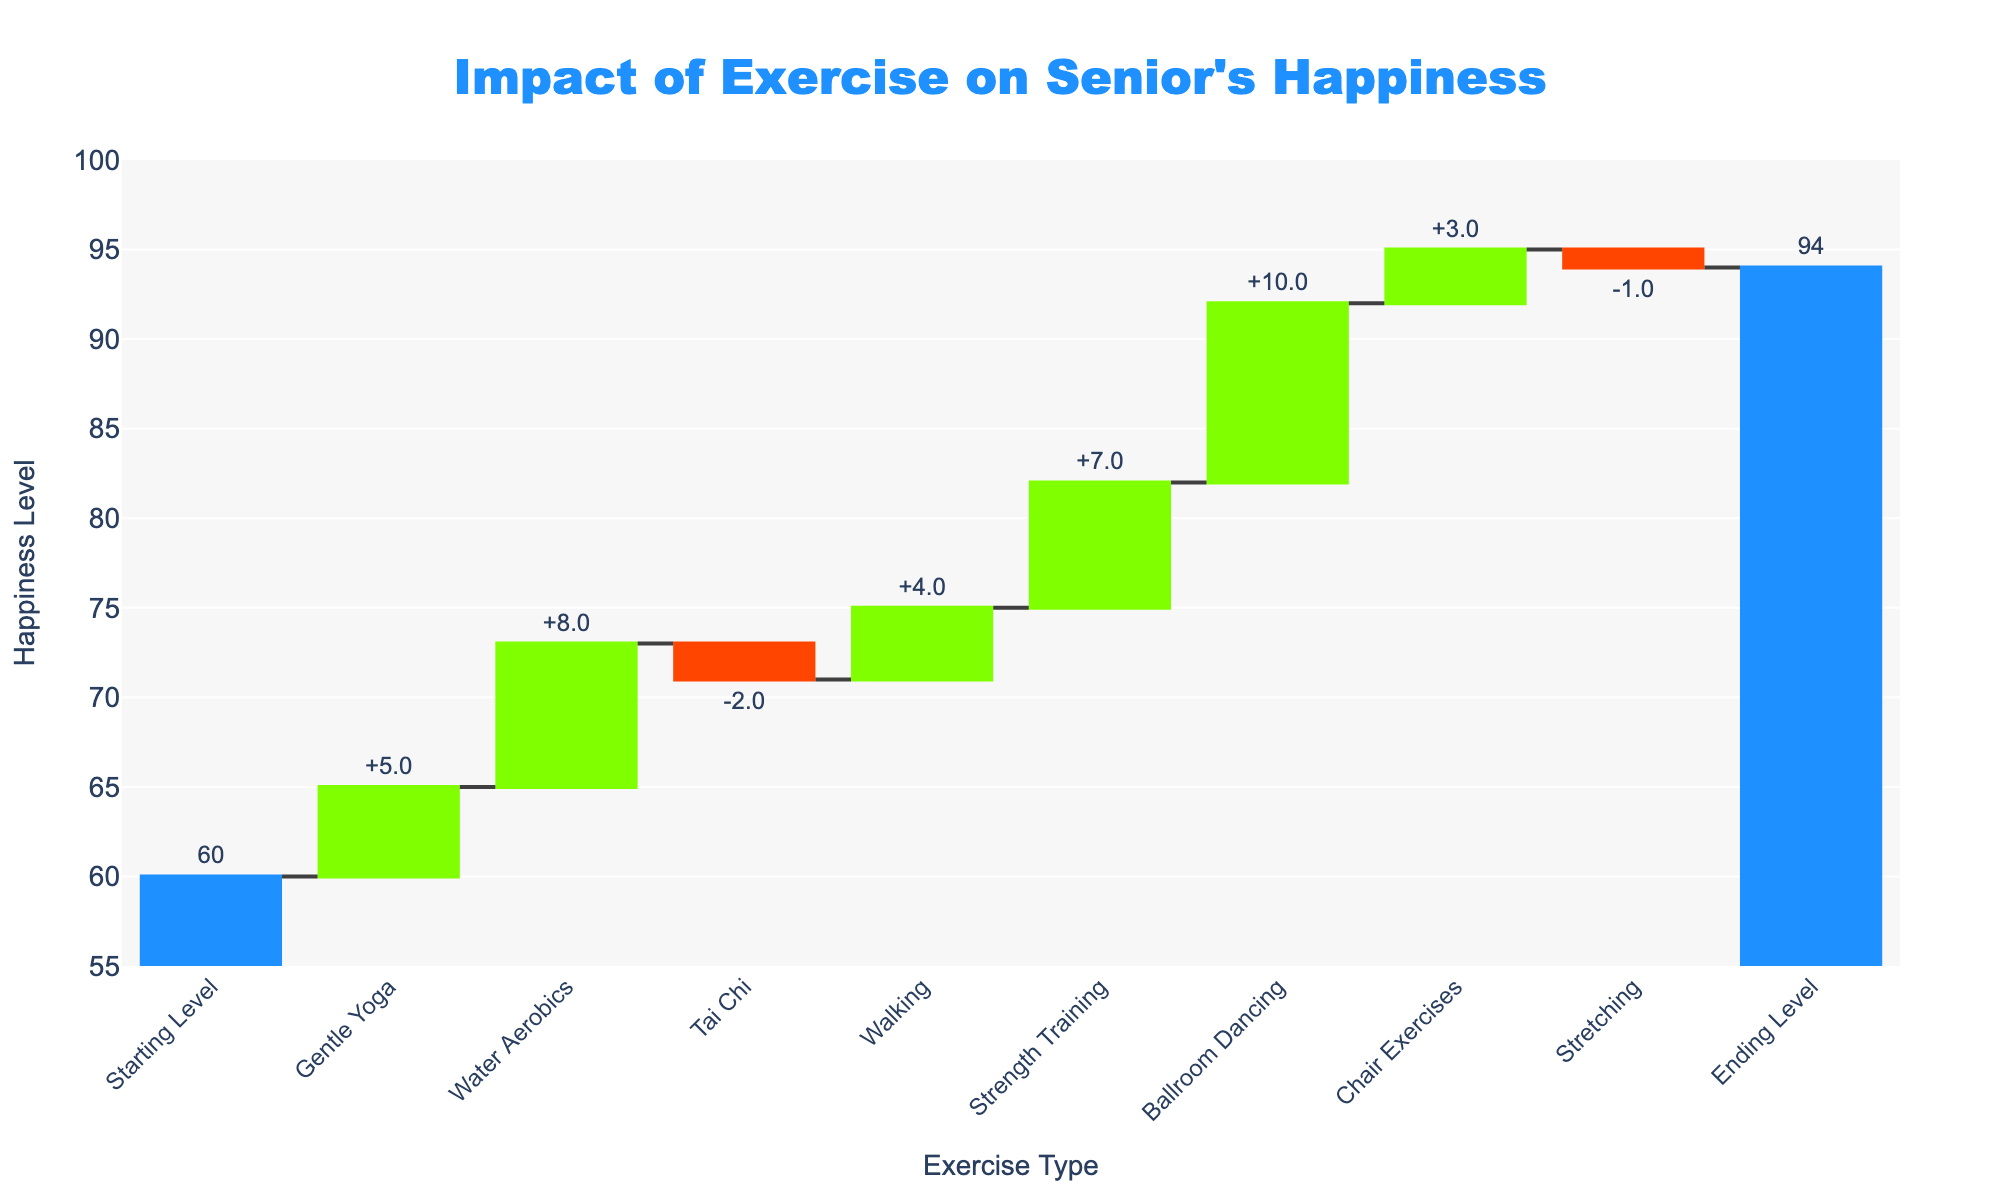What is the title of the chart? The title of the chart is usually displayed at the top and is meant to provide a summary of what the chart represents. In this chart, the title at the top is "Impact of Exercise on Senior's Happiness".
Answer: Impact of Exercise on Senior's Happiness What is the final happiness level at the end of the week? The final happiness level at the end of the week is shown by the last bar in the Waterfall Chart labeled "Ending Level". This bar has a value of 94, as indicated by the chart.
Answer: 94 Which exercise type contributed the most to the increase in happiness? To determine which exercise type contributed the most to the increase in happiness, we look for the highest positive value among the exercises listed. "Ballroom Dancing" has the largest increase of +10.
Answer: Ballroom Dancing What was the starting happiness level? The starting happiness level is shown at the beginning of the chart under "Starting Level". The value next to this label is 60.
Answer: 60 How much did Tai Chi decrease happiness? Tai Chi's impact is shown by a bar with a negative value. According to the chart, Tai Chi decreased happiness by -2.
Answer: 2 What is the total change in happiness from all activities? To calculate the total change in happiness, we sum up all the relative changes: +5 (Gentle Yoga) + 8 (Water Aerobics) - 2 (Tai Chi) + 4 (Walking) + 7 (Strength Training) + 10 (Ballroom Dancing) + 3 (Chair Exercises) - 1 (Stretching) = +34.
Answer: 34 Which exercises had a negative impact on happiness? Exercises that had a negative impact on happiness are indicated by bars with negative values. In this chart, Tai Chi (-2) and Stretching (-1) had a negative impact.
Answer: Tai Chi, Stretching What is the average happiness change from all positive exercises? First, identify the positive changes: +5, +8, +4, +7, +10, +3. Then, add them up: 5 + 8 + 4 + 7 + 10 + 3 = 37. There are 6 positive exercises, so the average is 37 / 6 ≈ 6.17.
Answer: 6.17 How does Strength Training compare to Walking in terms of happiness change? To compare Strength Training and Walking, we look at their respective bars. Strength Training increases happiness by +7, while Walking increases happiness by +4. Strength Training has a higher impact.
Answer: Strength Training > Walking 